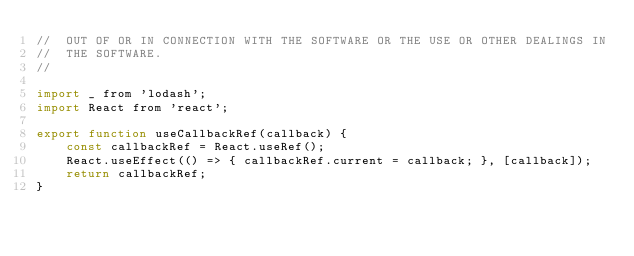Convert code to text. <code><loc_0><loc_0><loc_500><loc_500><_JavaScript_>//  OUT OF OR IN CONNECTION WITH THE SOFTWARE OR THE USE OR OTHER DEALINGS IN
//  THE SOFTWARE.
//

import _ from 'lodash';
import React from 'react';

export function useCallbackRef(callback) {
    const callbackRef = React.useRef();
    React.useEffect(() => { callbackRef.current = callback; }, [callback]);
    return callbackRef;
}
</code> 